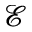<formula> <loc_0><loc_0><loc_500><loc_500>\mathcal { E }</formula> 